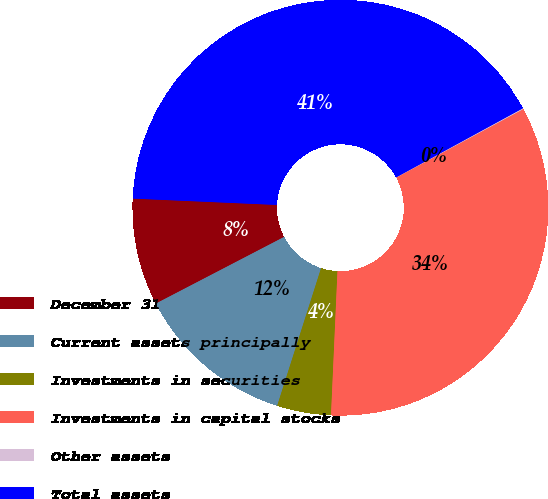<chart> <loc_0><loc_0><loc_500><loc_500><pie_chart><fcel>December 31<fcel>Current assets principally<fcel>Investments in securities<fcel>Investments in capital stocks<fcel>Other assets<fcel>Total assets<nl><fcel>8.33%<fcel>12.46%<fcel>4.2%<fcel>33.59%<fcel>0.07%<fcel>41.36%<nl></chart> 